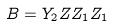<formula> <loc_0><loc_0><loc_500><loc_500>B = Y _ { 2 } Z Z _ { 1 } Z _ { 1 }</formula> 